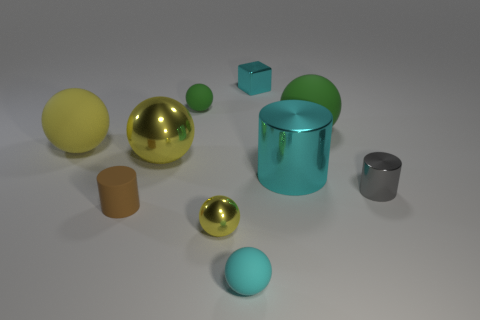How many brown things are either blocks or big metal objects?
Offer a very short reply. 0. Is the number of things in front of the big green thing greater than the number of tiny green matte balls?
Give a very brief answer. Yes. Is the size of the brown rubber cylinder the same as the gray shiny cylinder?
Ensure brevity in your answer.  Yes. There is a tiny cylinder that is made of the same material as the large cyan object; what color is it?
Offer a very short reply. Gray. What is the shape of the tiny matte thing that is the same color as the cube?
Ensure brevity in your answer.  Sphere. Are there an equal number of tiny brown matte cylinders right of the big yellow metallic object and big matte objects in front of the cyan rubber ball?
Your response must be concise. Yes. What shape is the matte thing that is left of the small brown matte cylinder that is behind the small yellow ball?
Keep it short and to the point. Sphere. There is another green thing that is the same shape as the small green matte thing; what is it made of?
Offer a terse response. Rubber. What color is the rubber cylinder that is the same size as the shiny block?
Your answer should be very brief. Brown. Is the number of small gray things in front of the brown matte cylinder the same as the number of tiny blue objects?
Provide a succinct answer. Yes. 